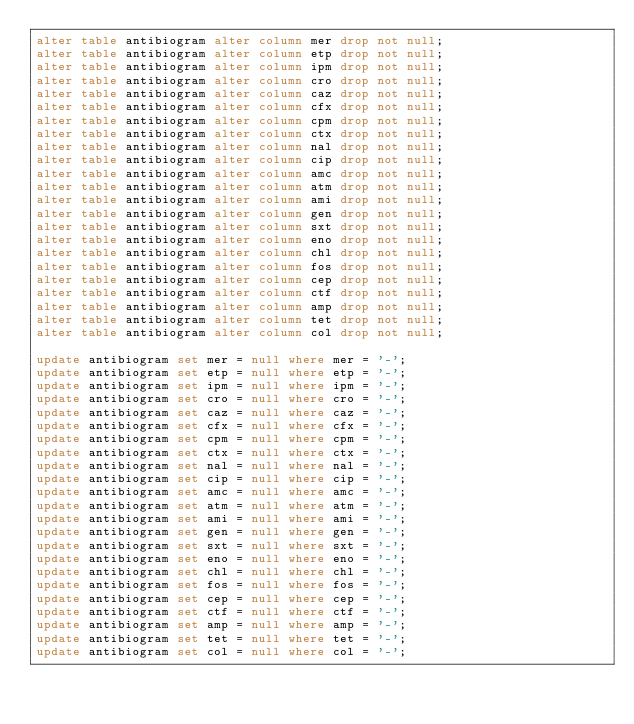<code> <loc_0><loc_0><loc_500><loc_500><_SQL_>alter table antibiogram alter column mer drop not null;
alter table antibiogram alter column etp drop not null;
alter table antibiogram alter column ipm drop not null;
alter table antibiogram alter column cro drop not null;
alter table antibiogram alter column caz drop not null;
alter table antibiogram alter column cfx drop not null;
alter table antibiogram alter column cpm drop not null;
alter table antibiogram alter column ctx drop not null;
alter table antibiogram alter column nal drop not null;
alter table antibiogram alter column cip drop not null;
alter table antibiogram alter column amc drop not null;
alter table antibiogram alter column atm drop not null;
alter table antibiogram alter column ami drop not null;
alter table antibiogram alter column gen drop not null;
alter table antibiogram alter column sxt drop not null;
alter table antibiogram alter column eno drop not null;
alter table antibiogram alter column chl drop not null;
alter table antibiogram alter column fos drop not null;
alter table antibiogram alter column cep drop not null;
alter table antibiogram alter column ctf drop not null;
alter table antibiogram alter column amp drop not null;
alter table antibiogram alter column tet drop not null;
alter table antibiogram alter column col drop not null;

update antibiogram set mer = null where mer = '-';
update antibiogram set etp = null where etp = '-';
update antibiogram set ipm = null where ipm = '-';
update antibiogram set cro = null where cro = '-';
update antibiogram set caz = null where caz = '-';
update antibiogram set cfx = null where cfx = '-';
update antibiogram set cpm = null where cpm = '-';
update antibiogram set ctx = null where ctx = '-';
update antibiogram set nal = null where nal = '-';
update antibiogram set cip = null where cip = '-';
update antibiogram set amc = null where amc = '-';
update antibiogram set atm = null where atm = '-';
update antibiogram set ami = null where ami = '-';
update antibiogram set gen = null where gen = '-';
update antibiogram set sxt = null where sxt = '-';
update antibiogram set eno = null where eno = '-';
update antibiogram set chl = null where chl = '-';
update antibiogram set fos = null where fos = '-';
update antibiogram set cep = null where cep = '-';
update antibiogram set ctf = null where ctf = '-';
update antibiogram set amp = null where amp = '-';
update antibiogram set tet = null where tet = '-';
update antibiogram set col = null where col = '-';</code> 